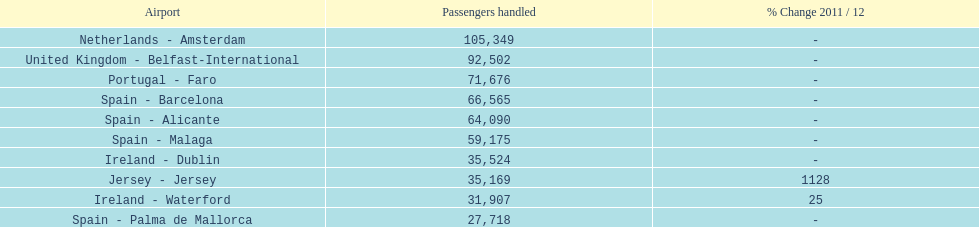How many travelers were managed at an airport in spain? 217,548. 